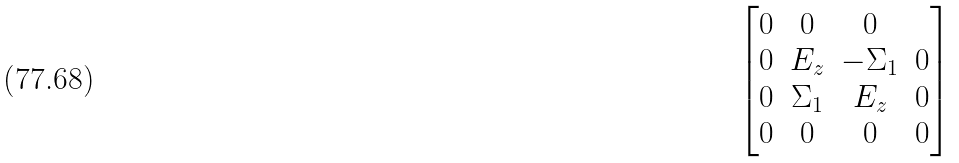<formula> <loc_0><loc_0><loc_500><loc_500>\begin{bmatrix} 0 & 0 & 0 & \\ 0 & E _ { z } & - \Sigma _ { 1 } & 0 \\ 0 & \Sigma _ { 1 } & E _ { z } & 0 \\ 0 & 0 & 0 & 0 \end{bmatrix}</formula> 